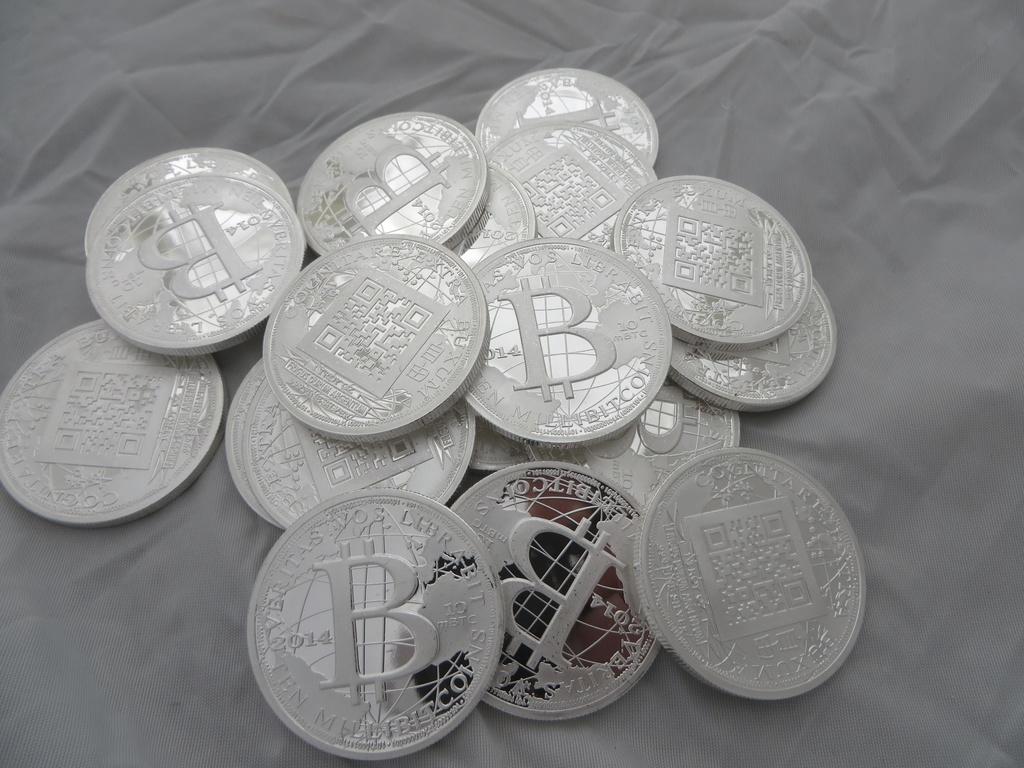What letter is most prominent on the coins?
Give a very brief answer. B. 